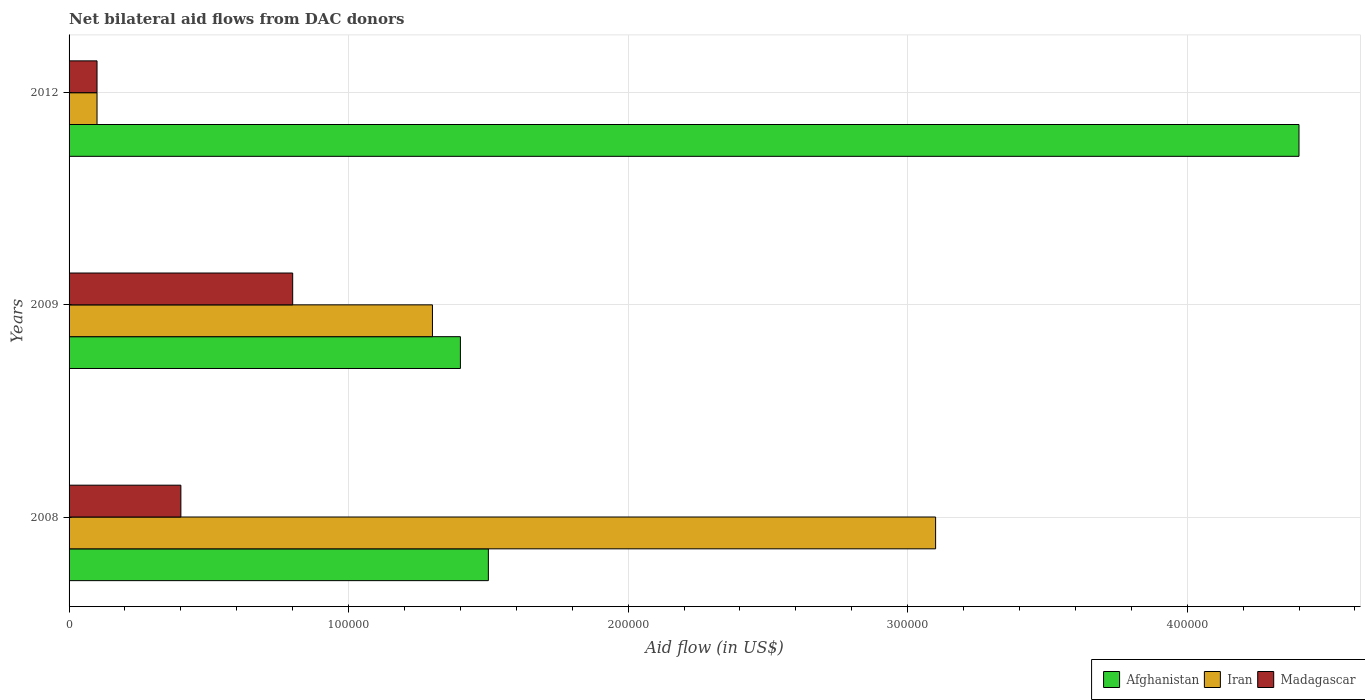How many different coloured bars are there?
Your response must be concise. 3. Are the number of bars per tick equal to the number of legend labels?
Offer a terse response. Yes. Are the number of bars on each tick of the Y-axis equal?
Your answer should be very brief. Yes. How many bars are there on the 3rd tick from the bottom?
Give a very brief answer. 3. What is the net bilateral aid flow in Afghanistan in 2012?
Your answer should be compact. 4.40e+05. Across all years, what is the minimum net bilateral aid flow in Madagascar?
Provide a succinct answer. 10000. In which year was the net bilateral aid flow in Iran minimum?
Offer a very short reply. 2012. What is the total net bilateral aid flow in Afghanistan in the graph?
Provide a short and direct response. 7.30e+05. What is the average net bilateral aid flow in Madagascar per year?
Give a very brief answer. 4.33e+04. In the year 2009, what is the difference between the net bilateral aid flow in Madagascar and net bilateral aid flow in Afghanistan?
Your answer should be very brief. -6.00e+04. Is the net bilateral aid flow in Iran in 2008 less than that in 2012?
Your answer should be compact. No. Is the difference between the net bilateral aid flow in Madagascar in 2008 and 2012 greater than the difference between the net bilateral aid flow in Afghanistan in 2008 and 2012?
Your answer should be very brief. Yes. What is the difference between the highest and the lowest net bilateral aid flow in Madagascar?
Offer a terse response. 7.00e+04. What does the 1st bar from the top in 2009 represents?
Offer a terse response. Madagascar. What does the 2nd bar from the bottom in 2008 represents?
Offer a very short reply. Iran. Is it the case that in every year, the sum of the net bilateral aid flow in Afghanistan and net bilateral aid flow in Iran is greater than the net bilateral aid flow in Madagascar?
Offer a very short reply. Yes. Are all the bars in the graph horizontal?
Keep it short and to the point. Yes. What is the difference between two consecutive major ticks on the X-axis?
Your answer should be very brief. 1.00e+05. Are the values on the major ticks of X-axis written in scientific E-notation?
Your answer should be compact. No. Does the graph contain grids?
Make the answer very short. Yes. How many legend labels are there?
Keep it short and to the point. 3. What is the title of the graph?
Make the answer very short. Net bilateral aid flows from DAC donors. What is the label or title of the X-axis?
Make the answer very short. Aid flow (in US$). What is the Aid flow (in US$) of Afghanistan in 2008?
Keep it short and to the point. 1.50e+05. What is the Aid flow (in US$) in Madagascar in 2008?
Give a very brief answer. 4.00e+04. What is the Aid flow (in US$) in Afghanistan in 2009?
Provide a succinct answer. 1.40e+05. What is the Aid flow (in US$) in Afghanistan in 2012?
Provide a short and direct response. 4.40e+05. What is the Aid flow (in US$) in Madagascar in 2012?
Ensure brevity in your answer.  10000. Across all years, what is the minimum Aid flow (in US$) of Afghanistan?
Keep it short and to the point. 1.40e+05. Across all years, what is the minimum Aid flow (in US$) in Madagascar?
Provide a short and direct response. 10000. What is the total Aid flow (in US$) of Afghanistan in the graph?
Make the answer very short. 7.30e+05. What is the total Aid flow (in US$) of Madagascar in the graph?
Provide a short and direct response. 1.30e+05. What is the difference between the Aid flow (in US$) of Iran in 2008 and that in 2009?
Provide a succinct answer. 1.80e+05. What is the difference between the Aid flow (in US$) in Iran in 2008 and that in 2012?
Ensure brevity in your answer.  3.00e+05. What is the difference between the Aid flow (in US$) in Madagascar in 2008 and that in 2012?
Ensure brevity in your answer.  3.00e+04. What is the difference between the Aid flow (in US$) in Madagascar in 2009 and that in 2012?
Provide a short and direct response. 7.00e+04. What is the difference between the Aid flow (in US$) in Iran in 2008 and the Aid flow (in US$) in Madagascar in 2009?
Your answer should be very brief. 2.30e+05. What is the difference between the Aid flow (in US$) of Afghanistan in 2008 and the Aid flow (in US$) of Iran in 2012?
Make the answer very short. 1.40e+05. What is the difference between the Aid flow (in US$) in Iran in 2008 and the Aid flow (in US$) in Madagascar in 2012?
Your answer should be very brief. 3.00e+05. What is the difference between the Aid flow (in US$) of Iran in 2009 and the Aid flow (in US$) of Madagascar in 2012?
Your answer should be compact. 1.20e+05. What is the average Aid flow (in US$) in Afghanistan per year?
Your answer should be very brief. 2.43e+05. What is the average Aid flow (in US$) of Madagascar per year?
Offer a very short reply. 4.33e+04. In the year 2008, what is the difference between the Aid flow (in US$) in Afghanistan and Aid flow (in US$) in Iran?
Ensure brevity in your answer.  -1.60e+05. In the year 2008, what is the difference between the Aid flow (in US$) in Afghanistan and Aid flow (in US$) in Madagascar?
Provide a succinct answer. 1.10e+05. In the year 2008, what is the difference between the Aid flow (in US$) of Iran and Aid flow (in US$) of Madagascar?
Your answer should be very brief. 2.70e+05. In the year 2009, what is the difference between the Aid flow (in US$) of Afghanistan and Aid flow (in US$) of Madagascar?
Give a very brief answer. 6.00e+04. In the year 2012, what is the difference between the Aid flow (in US$) in Afghanistan and Aid flow (in US$) in Madagascar?
Your response must be concise. 4.30e+05. In the year 2012, what is the difference between the Aid flow (in US$) in Iran and Aid flow (in US$) in Madagascar?
Offer a very short reply. 0. What is the ratio of the Aid flow (in US$) of Afghanistan in 2008 to that in 2009?
Your answer should be compact. 1.07. What is the ratio of the Aid flow (in US$) of Iran in 2008 to that in 2009?
Provide a succinct answer. 2.38. What is the ratio of the Aid flow (in US$) in Afghanistan in 2008 to that in 2012?
Offer a very short reply. 0.34. What is the ratio of the Aid flow (in US$) of Iran in 2008 to that in 2012?
Give a very brief answer. 31. What is the ratio of the Aid flow (in US$) in Madagascar in 2008 to that in 2012?
Ensure brevity in your answer.  4. What is the ratio of the Aid flow (in US$) of Afghanistan in 2009 to that in 2012?
Your response must be concise. 0.32. What is the ratio of the Aid flow (in US$) of Iran in 2009 to that in 2012?
Ensure brevity in your answer.  13. What is the difference between the highest and the lowest Aid flow (in US$) of Iran?
Make the answer very short. 3.00e+05. What is the difference between the highest and the lowest Aid flow (in US$) of Madagascar?
Provide a succinct answer. 7.00e+04. 